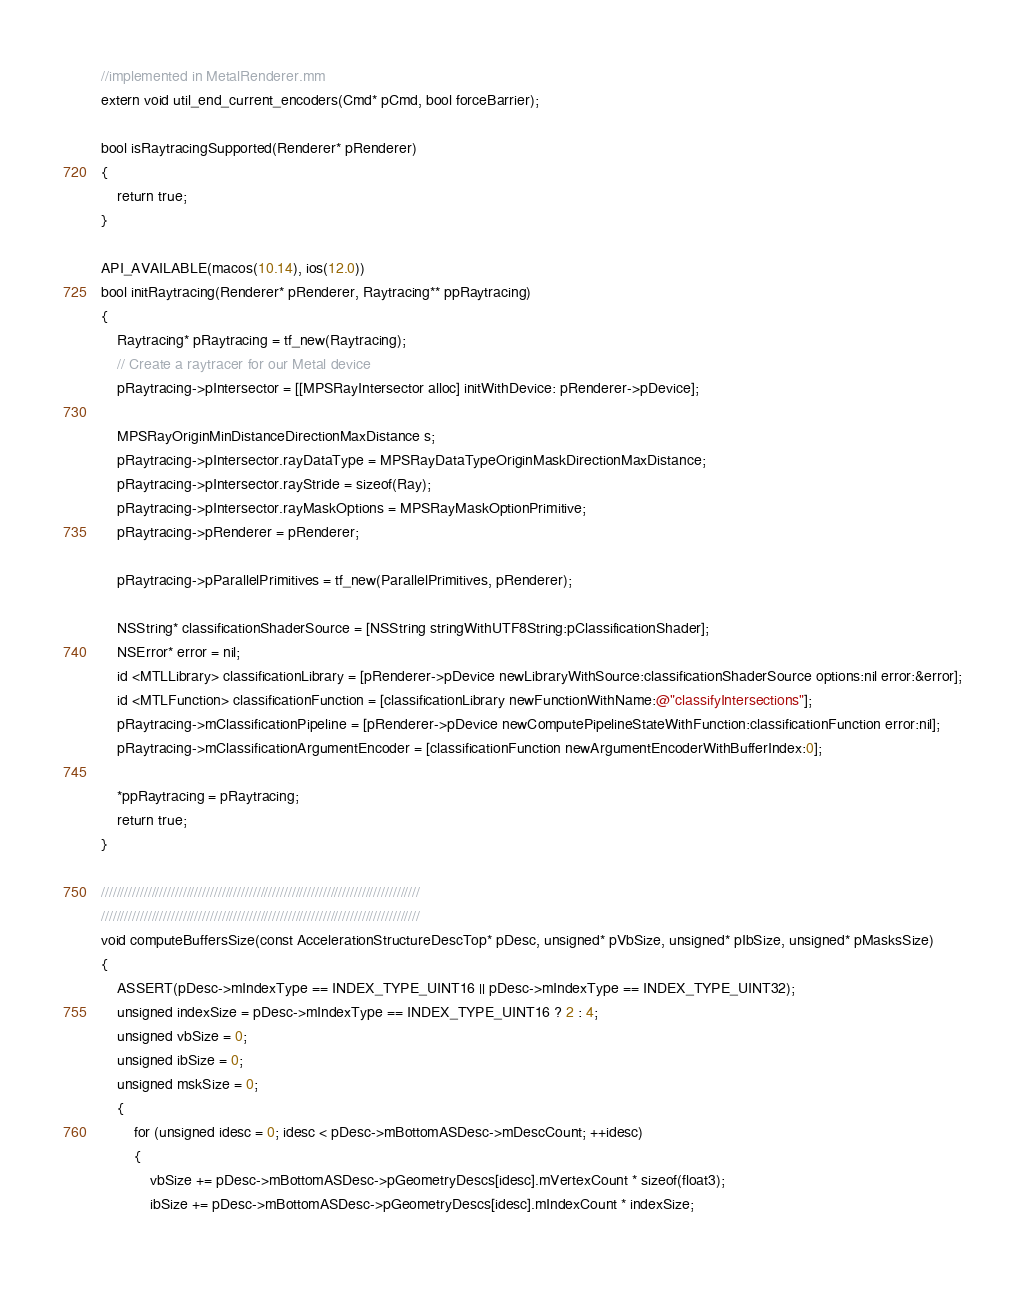Convert code to text. <code><loc_0><loc_0><loc_500><loc_500><_ObjectiveC_>//implemented in MetalRenderer.mm
extern void util_end_current_encoders(Cmd* pCmd, bool forceBarrier);

bool isRaytracingSupported(Renderer* pRenderer)
{
	return true;
}

API_AVAILABLE(macos(10.14), ios(12.0))
bool initRaytracing(Renderer* pRenderer, Raytracing** ppRaytracing)
{
	Raytracing* pRaytracing = tf_new(Raytracing);
	// Create a raytracer for our Metal device
	pRaytracing->pIntersector = [[MPSRayIntersector alloc] initWithDevice: pRenderer->pDevice];
	
	MPSRayOriginMinDistanceDirectionMaxDistance s;
	pRaytracing->pIntersector.rayDataType = MPSRayDataTypeOriginMaskDirectionMaxDistance;
	pRaytracing->pIntersector.rayStride = sizeof(Ray);
	pRaytracing->pIntersector.rayMaskOptions = MPSRayMaskOptionPrimitive;
	pRaytracing->pRenderer = pRenderer;
	
	pRaytracing->pParallelPrimitives = tf_new(ParallelPrimitives, pRenderer);
	
	NSString* classificationShaderSource = [NSString stringWithUTF8String:pClassificationShader];
	NSError* error = nil;
	id <MTLLibrary> classificationLibrary = [pRenderer->pDevice newLibraryWithSource:classificationShaderSource options:nil error:&error];
	id <MTLFunction> classificationFunction = [classificationLibrary newFunctionWithName:@"classifyIntersections"];
	pRaytracing->mClassificationPipeline = [pRenderer->pDevice newComputePipelineStateWithFunction:classificationFunction error:nil];
	pRaytracing->mClassificationArgumentEncoder = [classificationFunction newArgumentEncoderWithBufferIndex:0];
	
	*ppRaytracing = pRaytracing;
	return true;
}

//////////////////////////////////////////////////////////////////////////////////
//////////////////////////////////////////////////////////////////////////////////
void computeBuffersSize(const AccelerationStructureDescTop* pDesc, unsigned* pVbSize, unsigned* pIbSize, unsigned* pMasksSize)
{
	ASSERT(pDesc->mIndexType == INDEX_TYPE_UINT16 || pDesc->mIndexType == INDEX_TYPE_UINT32);
	unsigned indexSize = pDesc->mIndexType == INDEX_TYPE_UINT16 ? 2 : 4;
	unsigned vbSize = 0;
	unsigned ibSize = 0;
	unsigned mskSize = 0;
	{
		for (unsigned idesc = 0; idesc < pDesc->mBottomASDesc->mDescCount; ++idesc)
		{
			vbSize += pDesc->mBottomASDesc->pGeometryDescs[idesc].mVertexCount * sizeof(float3);
			ibSize += pDesc->mBottomASDesc->pGeometryDescs[idesc].mIndexCount * indexSize;
			</code> 